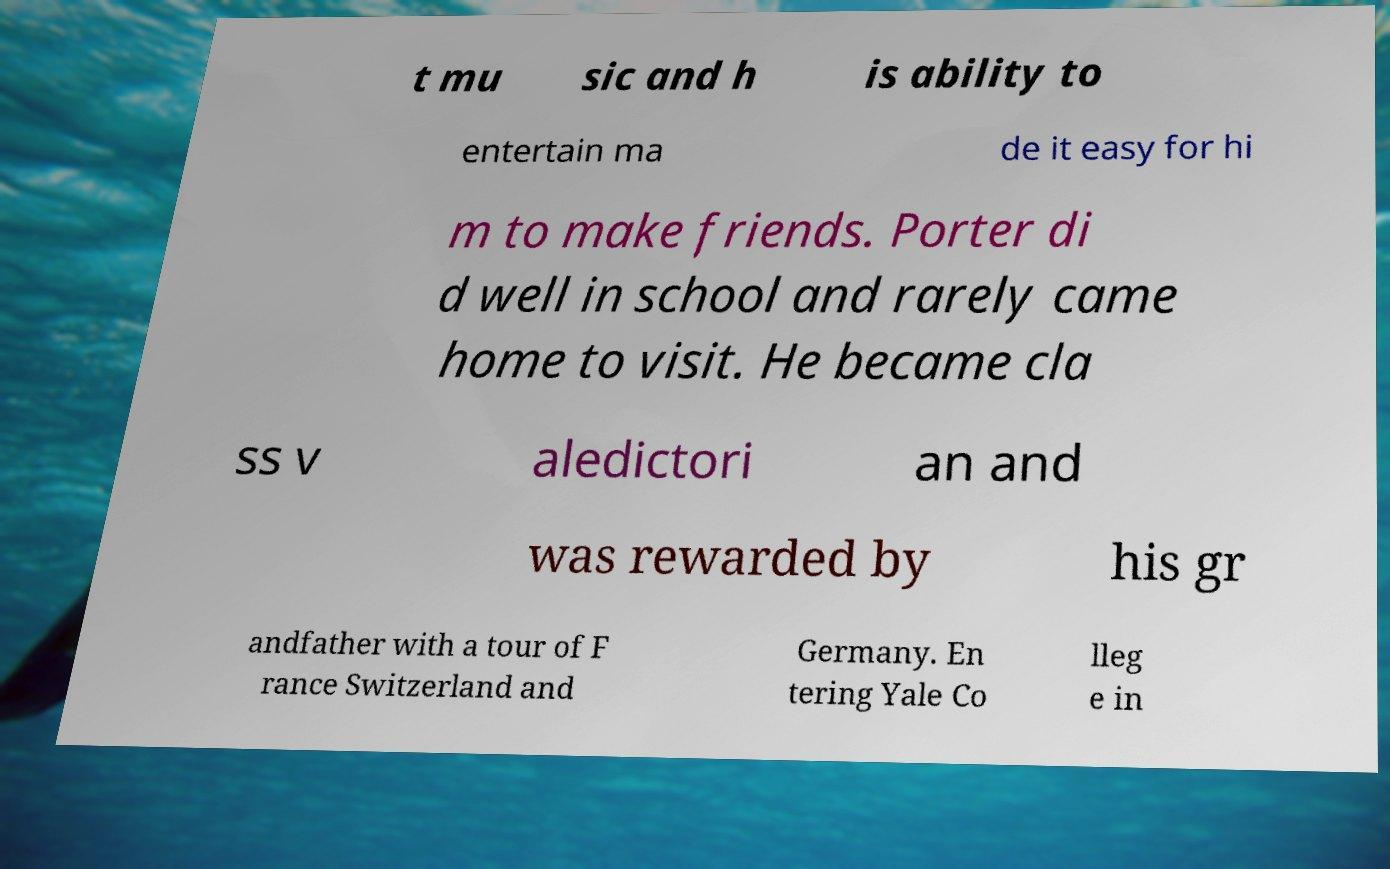I need the written content from this picture converted into text. Can you do that? t mu sic and h is ability to entertain ma de it easy for hi m to make friends. Porter di d well in school and rarely came home to visit. He became cla ss v aledictori an and was rewarded by his gr andfather with a tour of F rance Switzerland and Germany. En tering Yale Co lleg e in 